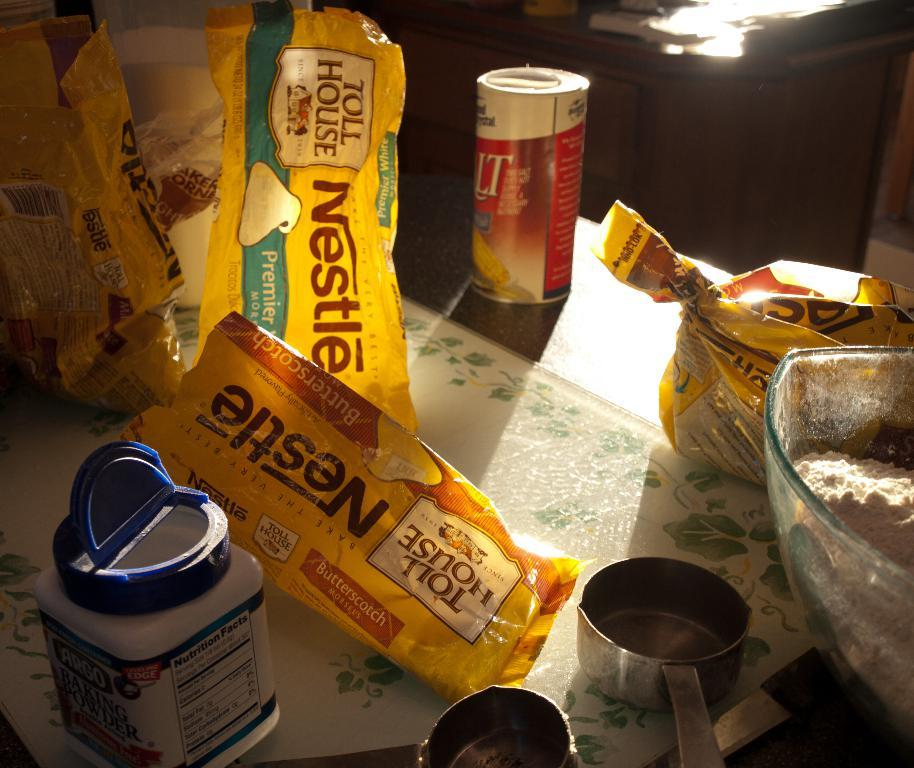<image>
Render a clear and concise summary of the photo. Ingredients on the counter include salt, baking powder, and Nestle's Toll House chocolate chips. 